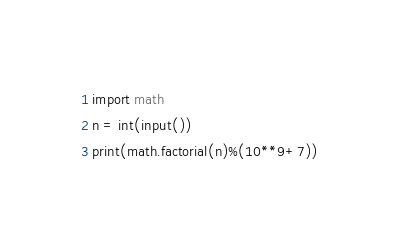<code> <loc_0><loc_0><loc_500><loc_500><_Python_>import math
n = int(input())
print(math.factorial(n)%(10**9+7))</code> 